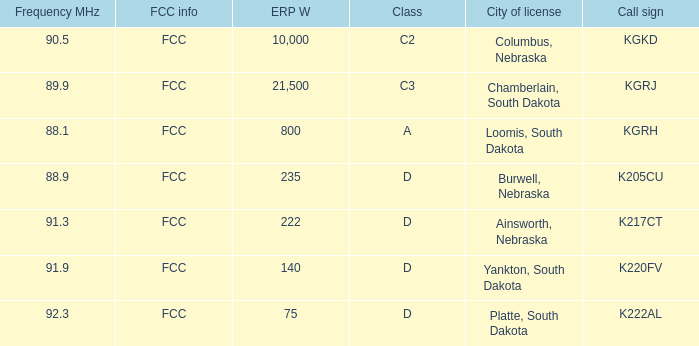What is the call sign with a 222 erp w? K217CT. 